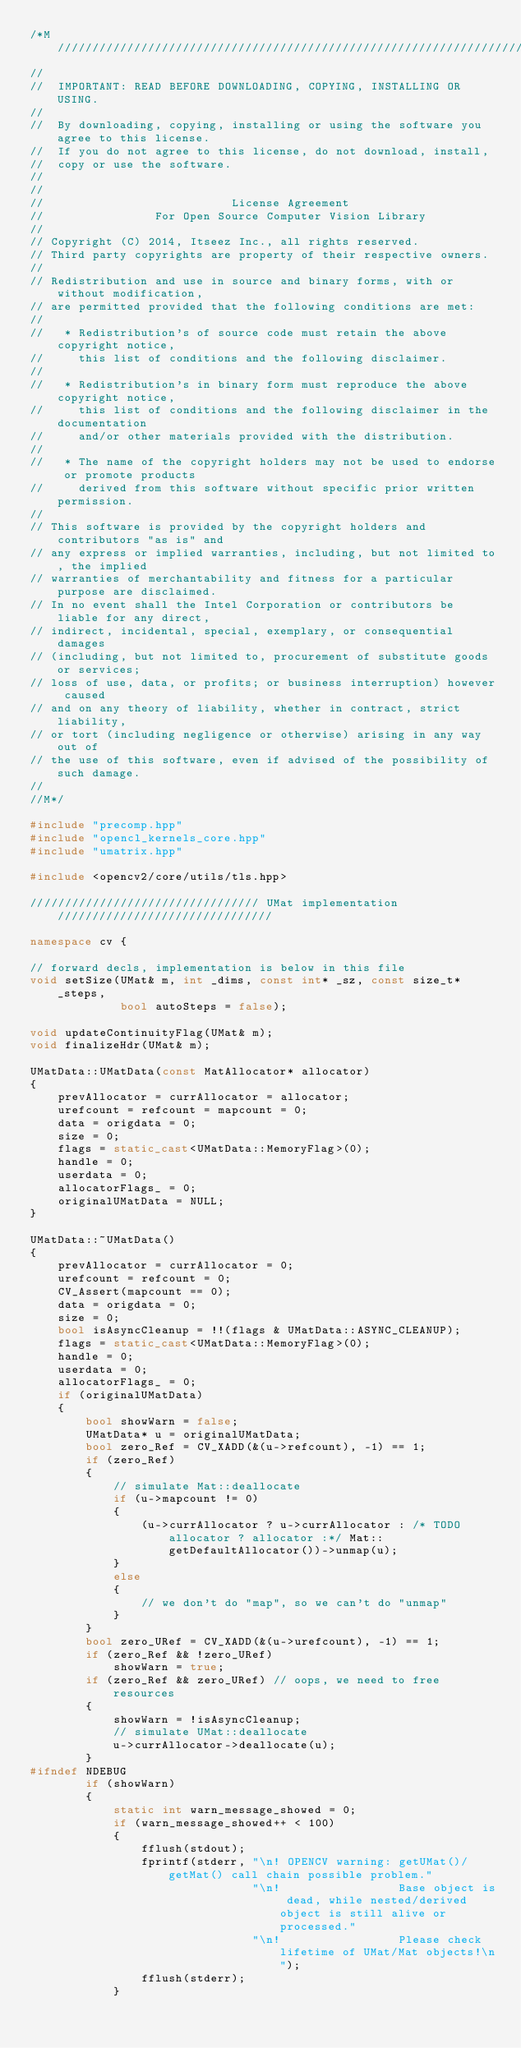Convert code to text. <code><loc_0><loc_0><loc_500><loc_500><_C++_>/*M///////////////////////////////////////////////////////////////////////////////////////
//
//  IMPORTANT: READ BEFORE DOWNLOADING, COPYING, INSTALLING OR USING.
//
//  By downloading, copying, installing or using the software you agree to this license.
//  If you do not agree to this license, do not download, install,
//  copy or use the software.
//
//
//                           License Agreement
//                For Open Source Computer Vision Library
//
// Copyright (C) 2014, Itseez Inc., all rights reserved.
// Third party copyrights are property of their respective owners.
//
// Redistribution and use in source and binary forms, with or without modification,
// are permitted provided that the following conditions are met:
//
//   * Redistribution's of source code must retain the above copyright notice,
//     this list of conditions and the following disclaimer.
//
//   * Redistribution's in binary form must reproduce the above copyright notice,
//     this list of conditions and the following disclaimer in the documentation
//     and/or other materials provided with the distribution.
//
//   * The name of the copyright holders may not be used to endorse or promote products
//     derived from this software without specific prior written permission.
//
// This software is provided by the copyright holders and contributors "as is" and
// any express or implied warranties, including, but not limited to, the implied
// warranties of merchantability and fitness for a particular purpose are disclaimed.
// In no event shall the Intel Corporation or contributors be liable for any direct,
// indirect, incidental, special, exemplary, or consequential damages
// (including, but not limited to, procurement of substitute goods or services;
// loss of use, data, or profits; or business interruption) however caused
// and on any theory of liability, whether in contract, strict liability,
// or tort (including negligence or otherwise) arising in any way out of
// the use of this software, even if advised of the possibility of such damage.
//
//M*/

#include "precomp.hpp"
#include "opencl_kernels_core.hpp"
#include "umatrix.hpp"

#include <opencv2/core/utils/tls.hpp>

///////////////////////////////// UMat implementation ///////////////////////////////

namespace cv {

// forward decls, implementation is below in this file
void setSize(UMat& m, int _dims, const int* _sz, const size_t* _steps,
             bool autoSteps = false);

void updateContinuityFlag(UMat& m);
void finalizeHdr(UMat& m);

UMatData::UMatData(const MatAllocator* allocator)
{
    prevAllocator = currAllocator = allocator;
    urefcount = refcount = mapcount = 0;
    data = origdata = 0;
    size = 0;
    flags = static_cast<UMatData::MemoryFlag>(0);
    handle = 0;
    userdata = 0;
    allocatorFlags_ = 0;
    originalUMatData = NULL;
}

UMatData::~UMatData()
{
    prevAllocator = currAllocator = 0;
    urefcount = refcount = 0;
    CV_Assert(mapcount == 0);
    data = origdata = 0;
    size = 0;
    bool isAsyncCleanup = !!(flags & UMatData::ASYNC_CLEANUP);
    flags = static_cast<UMatData::MemoryFlag>(0);
    handle = 0;
    userdata = 0;
    allocatorFlags_ = 0;
    if (originalUMatData)
    {
        bool showWarn = false;
        UMatData* u = originalUMatData;
        bool zero_Ref = CV_XADD(&(u->refcount), -1) == 1;
        if (zero_Ref)
        {
            // simulate Mat::deallocate
            if (u->mapcount != 0)
            {
                (u->currAllocator ? u->currAllocator : /* TODO allocator ? allocator :*/ Mat::getDefaultAllocator())->unmap(u);
            }
            else
            {
                // we don't do "map", so we can't do "unmap"
            }
        }
        bool zero_URef = CV_XADD(&(u->urefcount), -1) == 1;
        if (zero_Ref && !zero_URef)
            showWarn = true;
        if (zero_Ref && zero_URef) // oops, we need to free resources
        {
            showWarn = !isAsyncCleanup;
            // simulate UMat::deallocate
            u->currAllocator->deallocate(u);
        }
#ifndef NDEBUG
        if (showWarn)
        {
            static int warn_message_showed = 0;
            if (warn_message_showed++ < 100)
            {
                fflush(stdout);
                fprintf(stderr, "\n! OPENCV warning: getUMat()/getMat() call chain possible problem."
                                "\n!                 Base object is dead, while nested/derived object is still alive or processed."
                                "\n!                 Please check lifetime of UMat/Mat objects!\n");
                fflush(stderr);
            }</code> 